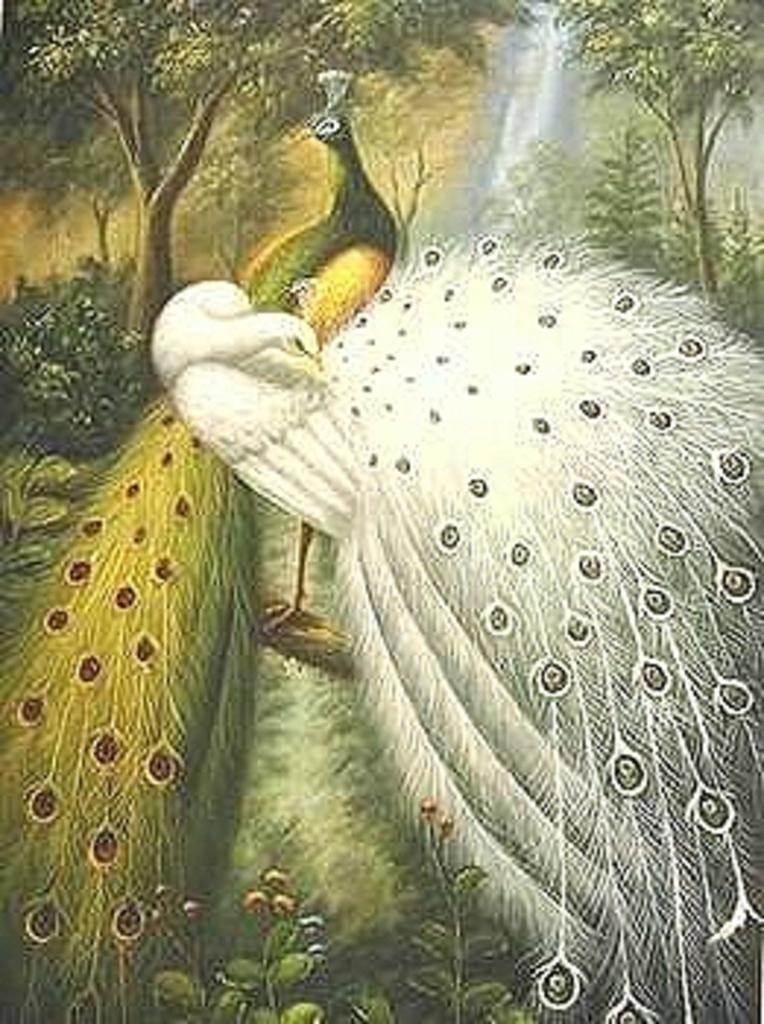What type of artwork is depicted in the image? The image appears to be a painting frame. What can be seen in the foreground of the painting? There are plants, grass, and peacocks in the foreground of the image. What is visible in the background of the painting? There are trees, plants, and a waterfall in the background of the image. What type of yam is being cooked in the image? There is no yam or cooking activity present in the image; it features a painting with plants, grass, peacocks, trees, plants, and a waterfall. What type of fabric is used to make the linen in the image? There is no linen present in the image; it is a painting featuring various natural elements. 